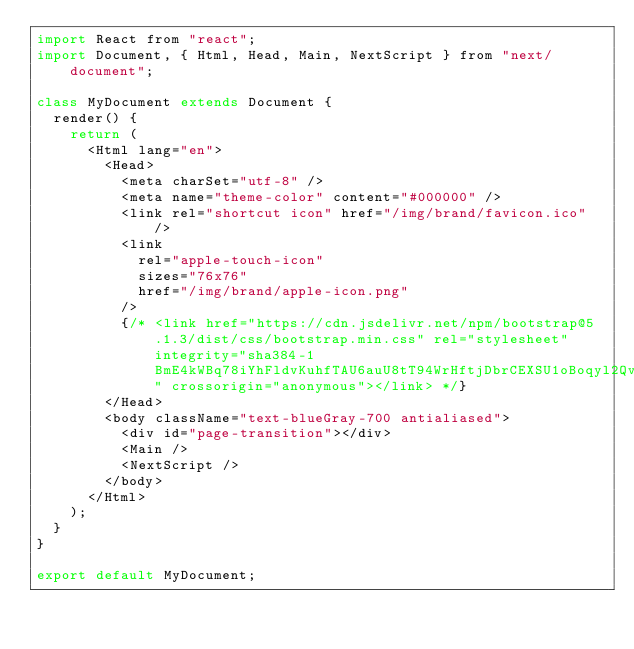<code> <loc_0><loc_0><loc_500><loc_500><_JavaScript_>import React from "react";
import Document, { Html, Head, Main, NextScript } from "next/document";

class MyDocument extends Document {
  render() {
    return (
      <Html lang="en">
        <Head>
          <meta charSet="utf-8" />
          <meta name="theme-color" content="#000000" />
          <link rel="shortcut icon" href="/img/brand/favicon.ico" />
          <link
            rel="apple-touch-icon"
            sizes="76x76"
            href="/img/brand/apple-icon.png"
          />
          {/* <link href="https://cdn.jsdelivr.net/npm/bootstrap@5.1.3/dist/css/bootstrap.min.css" rel="stylesheet" integrity="sha384-1BmE4kWBq78iYhFldvKuhfTAU6auU8tT94WrHftjDbrCEXSU1oBoqyl2QvZ6jIW3" crossorigin="anonymous"></link> */}
        </Head>
        <body className="text-blueGray-700 antialiased">
          <div id="page-transition"></div>
          <Main />
          <NextScript />
        </body>
      </Html>
    );
  }
}

export default MyDocument;
</code> 